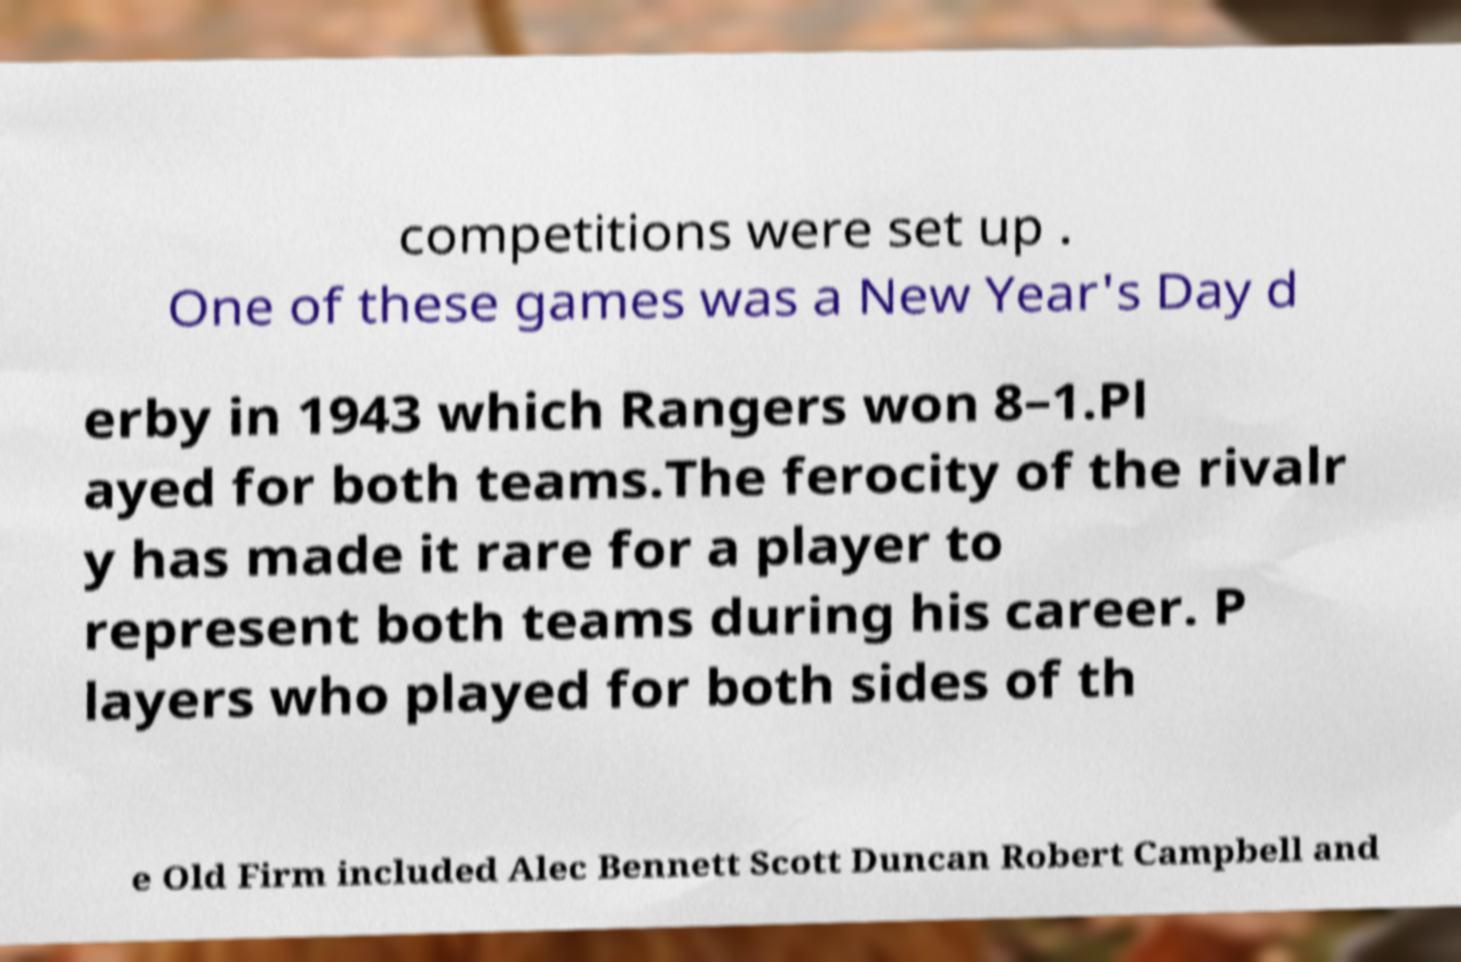Can you read and provide the text displayed in the image?This photo seems to have some interesting text. Can you extract and type it out for me? competitions were set up . One of these games was a New Year's Day d erby in 1943 which Rangers won 8–1.Pl ayed for both teams.The ferocity of the rivalr y has made it rare for a player to represent both teams during his career. P layers who played for both sides of th e Old Firm included Alec Bennett Scott Duncan Robert Campbell and 